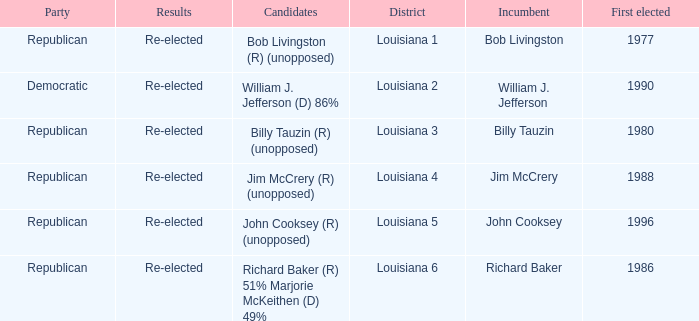Which district is represented by john cooksey? Louisiana 5. 